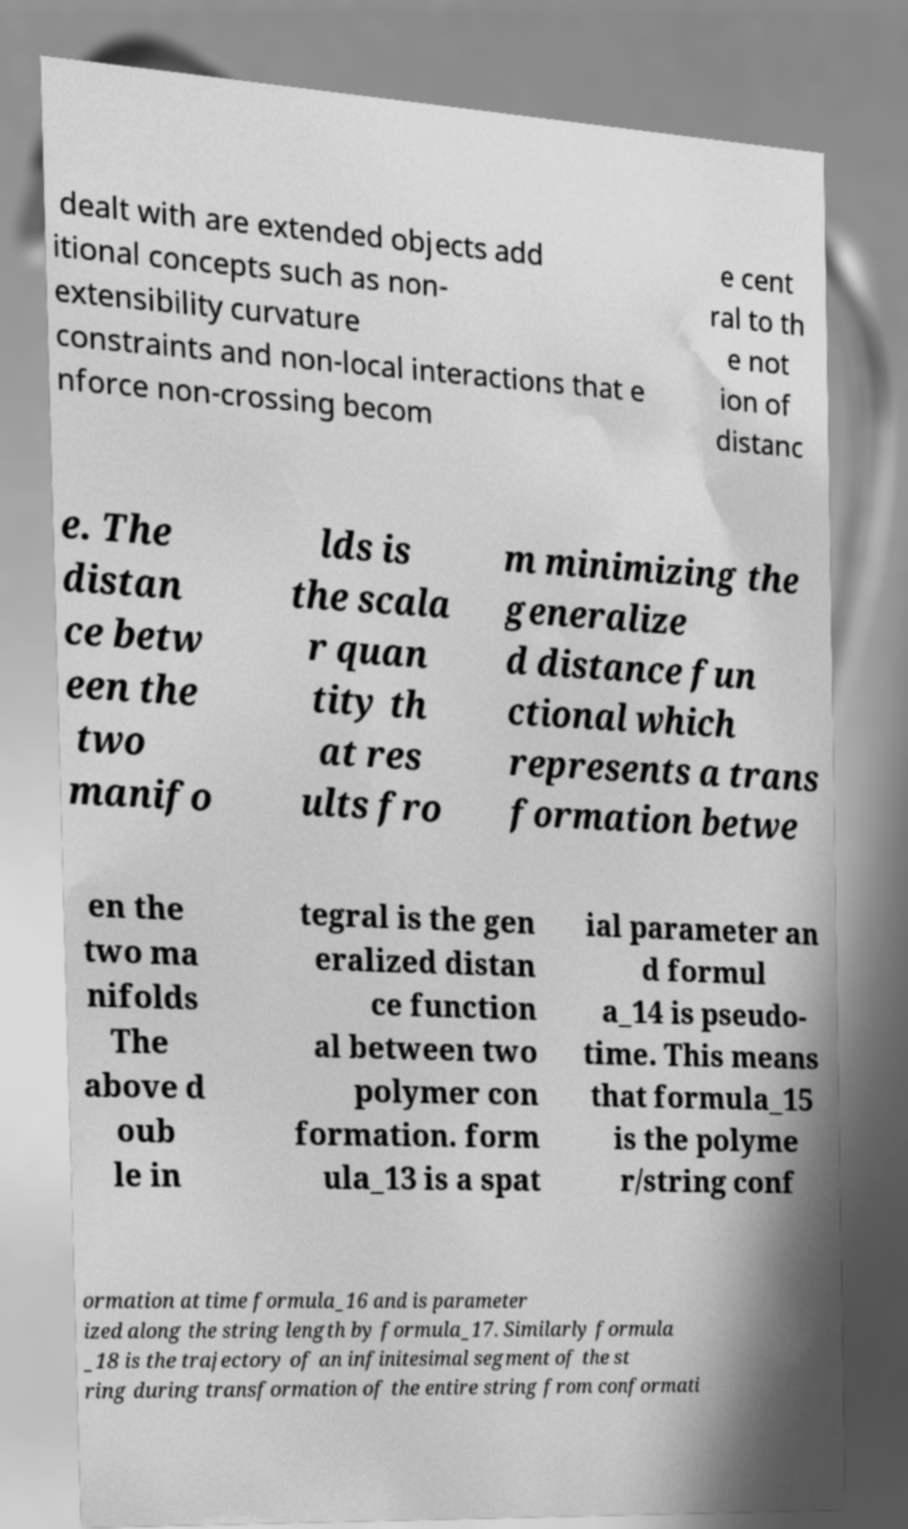I need the written content from this picture converted into text. Can you do that? dealt with are extended objects add itional concepts such as non- extensibility curvature constraints and non-local interactions that e nforce non-crossing becom e cent ral to th e not ion of distanc e. The distan ce betw een the two manifo lds is the scala r quan tity th at res ults fro m minimizing the generalize d distance fun ctional which represents a trans formation betwe en the two ma nifolds The above d oub le in tegral is the gen eralized distan ce function al between two polymer con formation. form ula_13 is a spat ial parameter an d formul a_14 is pseudo- time. This means that formula_15 is the polyme r/string conf ormation at time formula_16 and is parameter ized along the string length by formula_17. Similarly formula _18 is the trajectory of an infinitesimal segment of the st ring during transformation of the entire string from conformati 